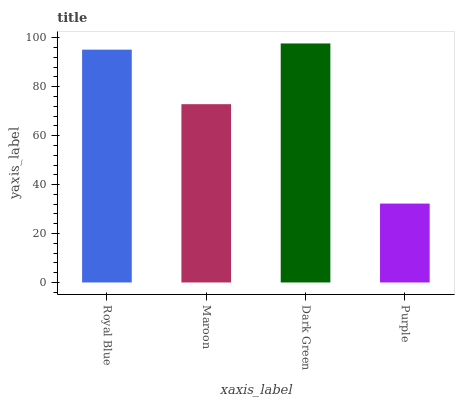Is Maroon the minimum?
Answer yes or no. No. Is Maroon the maximum?
Answer yes or no. No. Is Royal Blue greater than Maroon?
Answer yes or no. Yes. Is Maroon less than Royal Blue?
Answer yes or no. Yes. Is Maroon greater than Royal Blue?
Answer yes or no. No. Is Royal Blue less than Maroon?
Answer yes or no. No. Is Royal Blue the high median?
Answer yes or no. Yes. Is Maroon the low median?
Answer yes or no. Yes. Is Dark Green the high median?
Answer yes or no. No. Is Dark Green the low median?
Answer yes or no. No. 